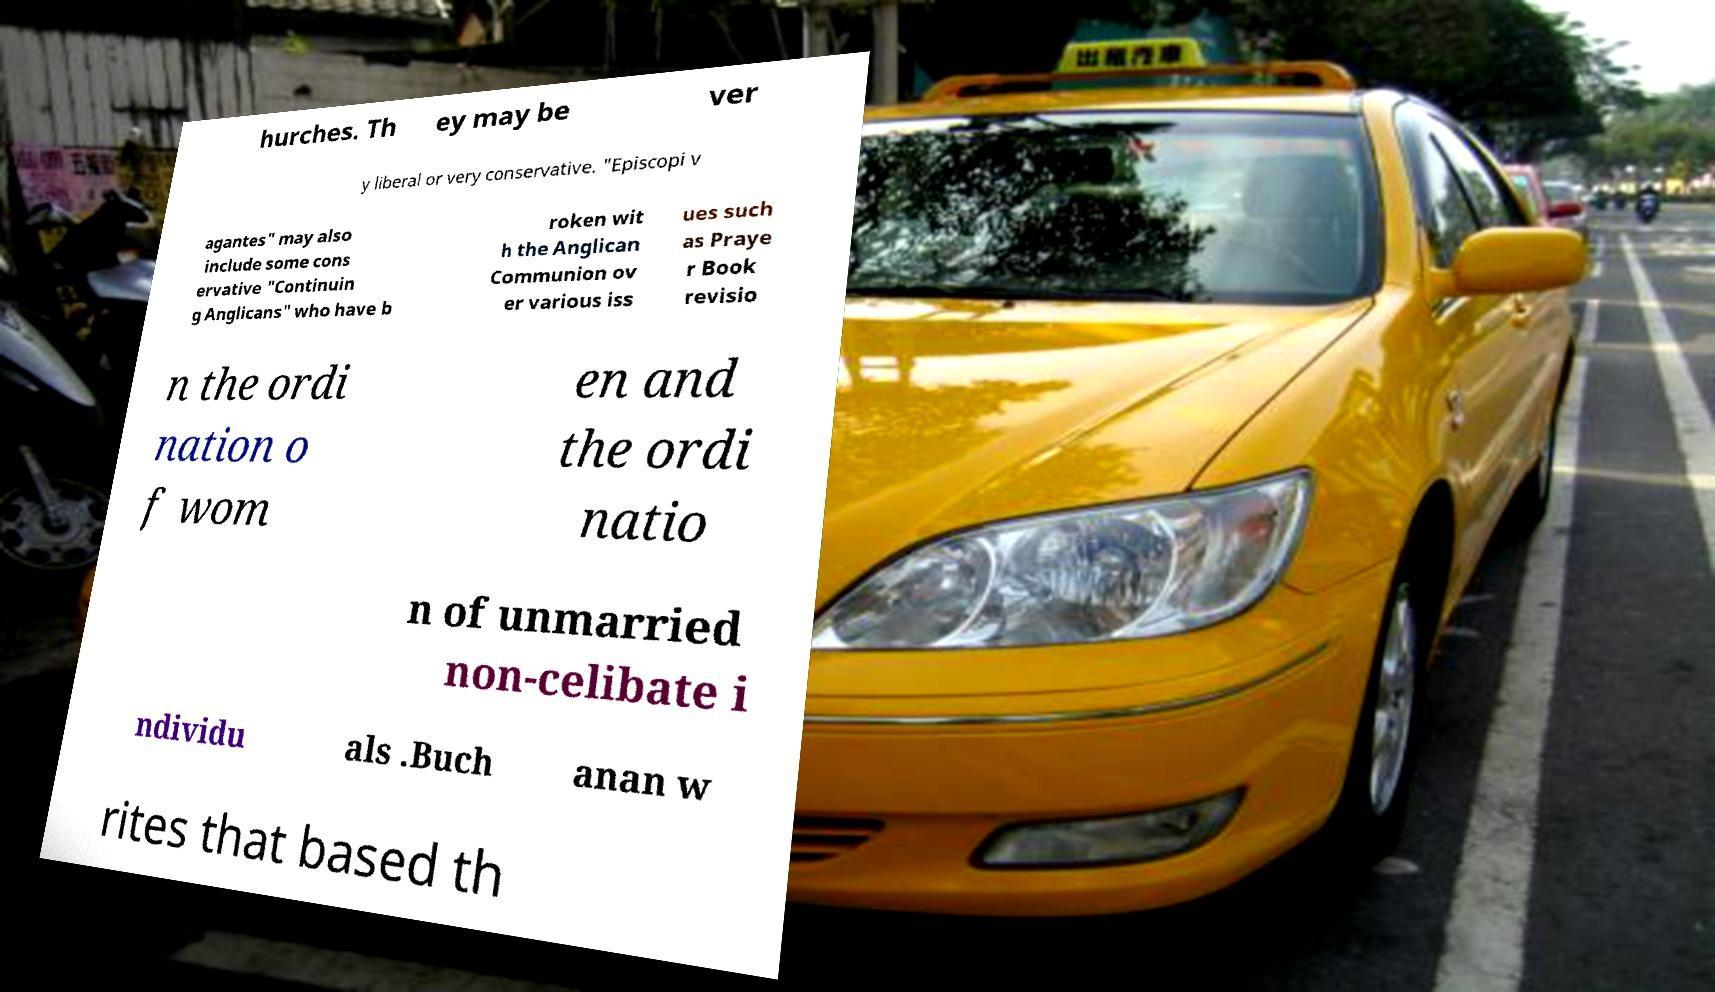Could you extract and type out the text from this image? hurches. Th ey may be ver y liberal or very conservative. "Episcopi v agantes" may also include some cons ervative "Continuin g Anglicans" who have b roken wit h the Anglican Communion ov er various iss ues such as Praye r Book revisio n the ordi nation o f wom en and the ordi natio n of unmarried non-celibate i ndividu als .Buch anan w rites that based th 